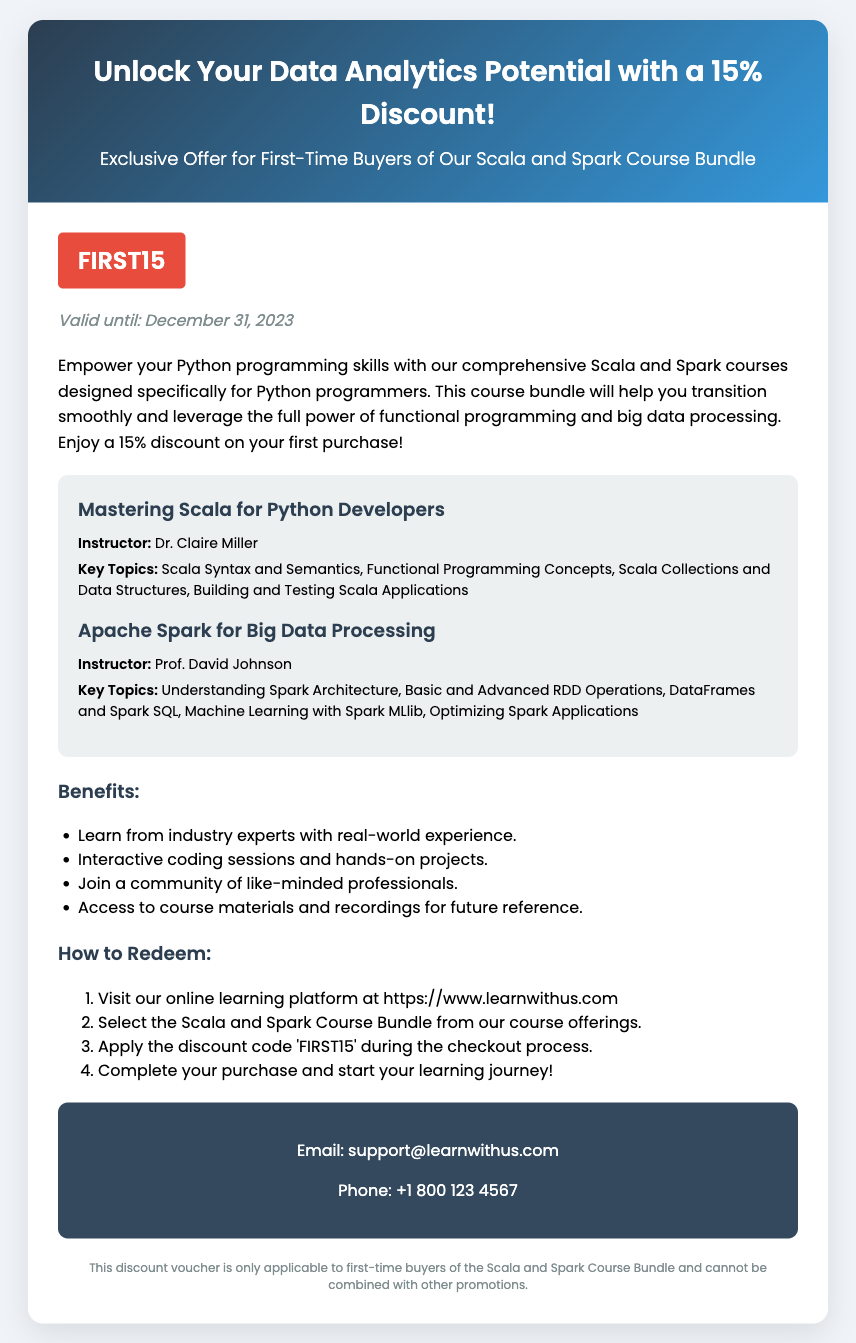What is the discount percentage? The discount percentage mentioned in the document is explicitly stated as 15%.
Answer: 15% Who is the instructor for the Scala course? The name of the instructor for the Scala course is provided in the course details section.
Answer: Dr. Claire Miller What is the validity date of the voucher? The validity date is specified clearly, indicating when the voucher expires.
Answer: December 31, 2023 What is the discount code for the voucher? The document highlights the specific discount code to be used for the offer.
Answer: FIRST15 What are two key topics covered in the Spark course? The course details include key topics, from which two can be selected to answer the question.
Answer: Understanding Spark Architecture, DataFrames and Spark SQL What benefits are mentioned for taking the courses? The document lists various benefits, allowing identification of specific advantages for potential students.
Answer: Learn from industry experts, Interactive coding sessions How can the voucher be redeemed? The document provides a step-by-step list for redeeming the voucher which can be summarized.
Answer: Apply the discount code during checkout What is the contact email for support? The document contains specific contact information for inquiries related to the courses.
Answer: support@learnwithus.com 